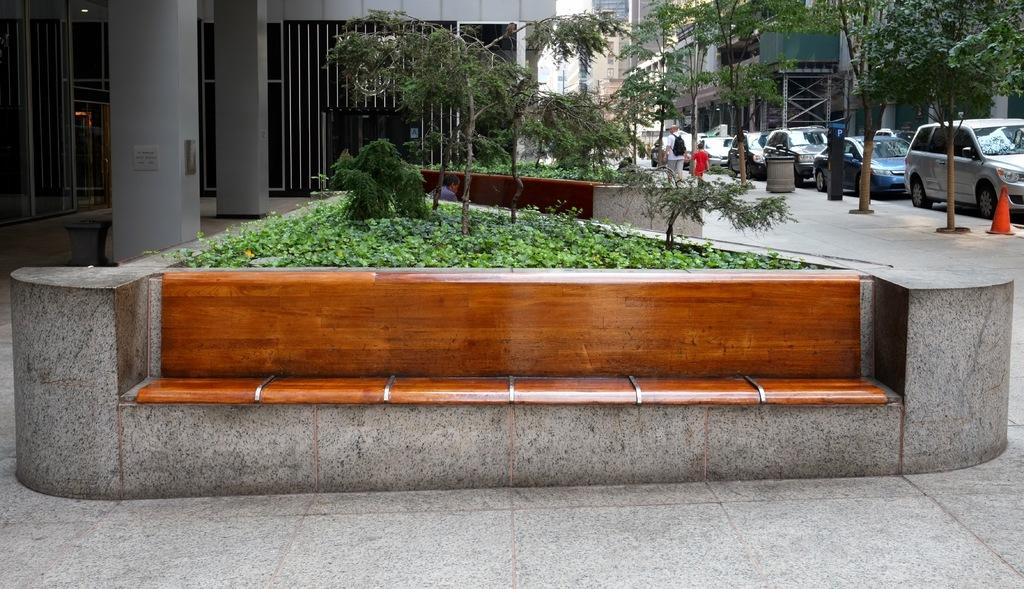What type of structures can be seen in the image? There are buildings in the image. the image. Who or what else is present in the image? There are persons and cars in the image. What type of vegetation is visible in the image? There are trees and grass in the image. What piece of furniture can be seen in the image? There is a bench in the image. What part of the natural environment is visible in the image? The sky is visible in the image. What type of beast is reading a book on the bench in the image? There is no beast present in the image, nor is there anyone reading a book on the bench. How much payment is required to enter the buildings in the image? There is no indication of any payment required to enter the buildings in the image. 